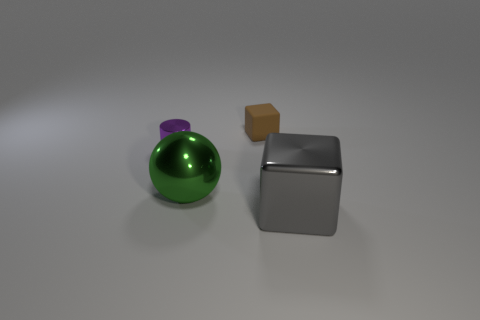Add 1 large brown matte cylinders. How many objects exist? 5 Subtract all spheres. How many objects are left? 3 Subtract all blue shiny objects. Subtract all metallic cubes. How many objects are left? 3 Add 2 metallic balls. How many metallic balls are left? 3 Add 4 tiny brown rubber blocks. How many tiny brown rubber blocks exist? 5 Subtract 0 brown cylinders. How many objects are left? 4 